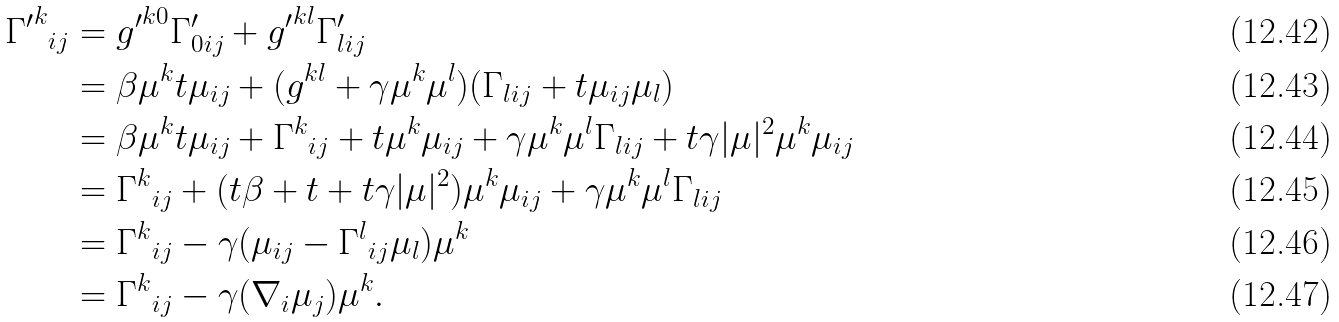Convert formula to latex. <formula><loc_0><loc_0><loc_500><loc_500>{ { \Gamma ^ { \prime } } ^ { k } } _ { i j } & = { g ^ { \prime } } ^ { k 0 } \Gamma ^ { \prime } _ { 0 i j } + { g ^ { \prime } } ^ { k l } \Gamma ^ { \prime } _ { l i j } \\ & = \beta \mu ^ { k } t \mu _ { i j } + ( g ^ { k l } + \gamma \mu ^ { k } \mu ^ { l } ) ( \Gamma _ { l i j } + t \mu _ { i j } \mu _ { l } ) \\ & = \beta \mu ^ { k } t \mu _ { i j } + { \Gamma ^ { k } } _ { i j } + t \mu ^ { k } \mu _ { i j } + \gamma \mu ^ { k } \mu ^ { l } \Gamma _ { l i j } + t \gamma | \mu | ^ { 2 } \mu ^ { k } \mu _ { i j } \\ & = { \Gamma ^ { k } } _ { i j } + ( t \beta + t + t \gamma | \mu | ^ { 2 } ) \mu ^ { k } \mu _ { i j } + \gamma \mu ^ { k } \mu ^ { l } \Gamma _ { l i j } \\ & = { \Gamma ^ { k } } _ { i j } - \gamma ( \mu _ { i j } - { \Gamma ^ { l } } _ { i j } \mu _ { l } ) \mu ^ { k } \\ & = { \Gamma ^ { k } } _ { i j } - \gamma ( \nabla _ { i } \mu _ { j } ) \mu ^ { k } .</formula> 